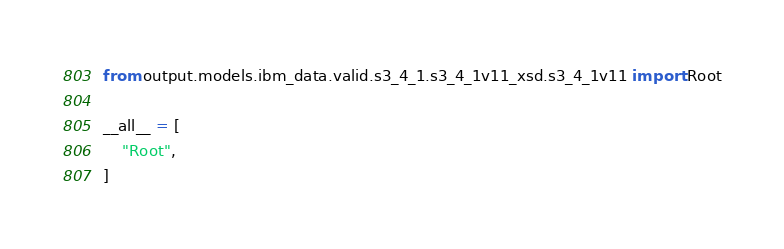Convert code to text. <code><loc_0><loc_0><loc_500><loc_500><_Python_>from output.models.ibm_data.valid.s3_4_1.s3_4_1v11_xsd.s3_4_1v11 import Root

__all__ = [
    "Root",
]
</code> 